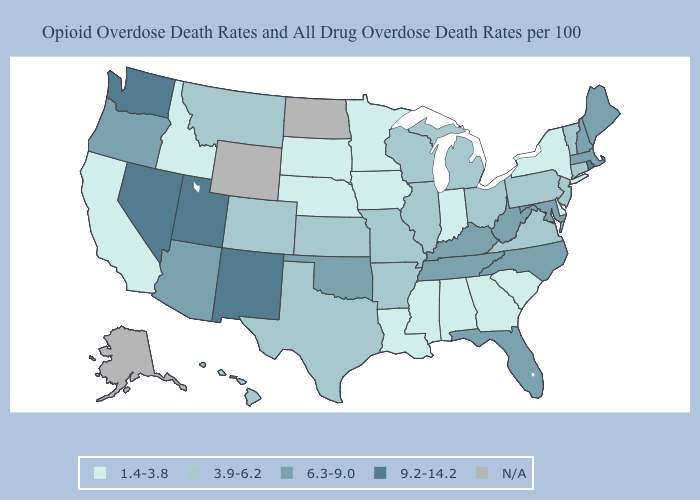Among the states that border North Dakota , which have the highest value?
Concise answer only. Montana. Does Louisiana have the lowest value in the USA?
Give a very brief answer. Yes. Which states have the lowest value in the USA?
Keep it brief. Alabama, California, Delaware, Georgia, Idaho, Indiana, Iowa, Louisiana, Minnesota, Mississippi, Nebraska, New York, South Carolina, South Dakota. Among the states that border Minnesota , does Iowa have the lowest value?
Give a very brief answer. Yes. How many symbols are there in the legend?
Short answer required. 5. Name the states that have a value in the range 1.4-3.8?
Give a very brief answer. Alabama, California, Delaware, Georgia, Idaho, Indiana, Iowa, Louisiana, Minnesota, Mississippi, Nebraska, New York, South Carolina, South Dakota. Among the states that border Tennessee , which have the lowest value?
Concise answer only. Alabama, Georgia, Mississippi. Name the states that have a value in the range 1.4-3.8?
Give a very brief answer. Alabama, California, Delaware, Georgia, Idaho, Indiana, Iowa, Louisiana, Minnesota, Mississippi, Nebraska, New York, South Carolina, South Dakota. What is the value of Maine?
Keep it brief. 6.3-9.0. Is the legend a continuous bar?
Keep it brief. No. What is the value of Nebraska?
Quick response, please. 1.4-3.8. Name the states that have a value in the range 3.9-6.2?
Concise answer only. Arkansas, Colorado, Connecticut, Hawaii, Illinois, Kansas, Michigan, Missouri, Montana, New Jersey, Ohio, Pennsylvania, Texas, Vermont, Virginia, Wisconsin. What is the highest value in the MidWest ?
Give a very brief answer. 3.9-6.2. 